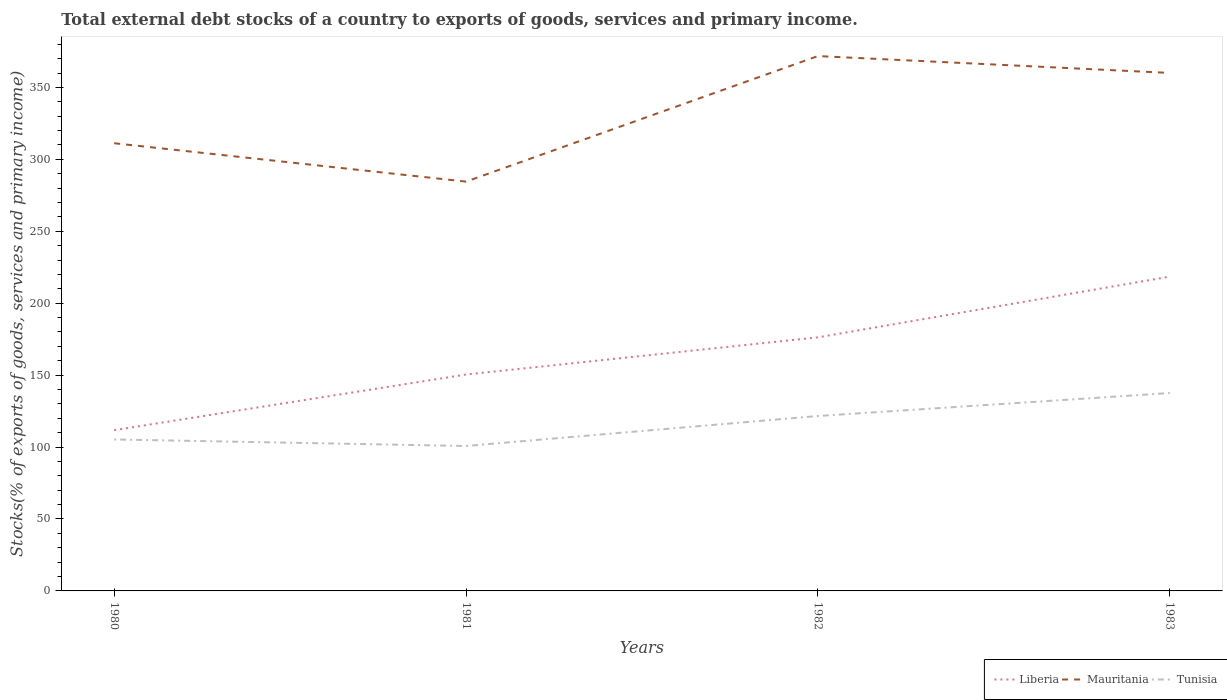Does the line corresponding to Mauritania intersect with the line corresponding to Tunisia?
Your response must be concise. No. Is the number of lines equal to the number of legend labels?
Provide a short and direct response. Yes. Across all years, what is the maximum total debt stocks in Tunisia?
Offer a terse response. 100.75. What is the total total debt stocks in Tunisia in the graph?
Offer a terse response. -16.3. What is the difference between the highest and the second highest total debt stocks in Tunisia?
Offer a very short reply. 36.81. What is the difference between the highest and the lowest total debt stocks in Mauritania?
Your answer should be very brief. 2. Is the total debt stocks in Liberia strictly greater than the total debt stocks in Mauritania over the years?
Provide a short and direct response. Yes. Are the values on the major ticks of Y-axis written in scientific E-notation?
Offer a terse response. No. Where does the legend appear in the graph?
Keep it short and to the point. Bottom right. How are the legend labels stacked?
Offer a terse response. Horizontal. What is the title of the graph?
Provide a succinct answer. Total external debt stocks of a country to exports of goods, services and primary income. Does "Virgin Islands" appear as one of the legend labels in the graph?
Offer a very short reply. No. What is the label or title of the Y-axis?
Give a very brief answer. Stocks(% of exports of goods, services and primary income). What is the Stocks(% of exports of goods, services and primary income) in Liberia in 1980?
Keep it short and to the point. 111.76. What is the Stocks(% of exports of goods, services and primary income) of Mauritania in 1980?
Make the answer very short. 311.19. What is the Stocks(% of exports of goods, services and primary income) of Tunisia in 1980?
Your response must be concise. 105.29. What is the Stocks(% of exports of goods, services and primary income) of Liberia in 1981?
Ensure brevity in your answer.  150.43. What is the Stocks(% of exports of goods, services and primary income) of Mauritania in 1981?
Keep it short and to the point. 284.52. What is the Stocks(% of exports of goods, services and primary income) in Tunisia in 1981?
Your answer should be very brief. 100.75. What is the Stocks(% of exports of goods, services and primary income) of Liberia in 1982?
Your response must be concise. 176.26. What is the Stocks(% of exports of goods, services and primary income) in Mauritania in 1982?
Make the answer very short. 371.77. What is the Stocks(% of exports of goods, services and primary income) of Tunisia in 1982?
Make the answer very short. 121.59. What is the Stocks(% of exports of goods, services and primary income) in Liberia in 1983?
Your answer should be very brief. 218.46. What is the Stocks(% of exports of goods, services and primary income) in Mauritania in 1983?
Your answer should be very brief. 360.05. What is the Stocks(% of exports of goods, services and primary income) in Tunisia in 1983?
Make the answer very short. 137.56. Across all years, what is the maximum Stocks(% of exports of goods, services and primary income) in Liberia?
Ensure brevity in your answer.  218.46. Across all years, what is the maximum Stocks(% of exports of goods, services and primary income) in Mauritania?
Your answer should be very brief. 371.77. Across all years, what is the maximum Stocks(% of exports of goods, services and primary income) of Tunisia?
Provide a short and direct response. 137.56. Across all years, what is the minimum Stocks(% of exports of goods, services and primary income) of Liberia?
Your answer should be compact. 111.76. Across all years, what is the minimum Stocks(% of exports of goods, services and primary income) in Mauritania?
Offer a very short reply. 284.52. Across all years, what is the minimum Stocks(% of exports of goods, services and primary income) of Tunisia?
Offer a terse response. 100.75. What is the total Stocks(% of exports of goods, services and primary income) of Liberia in the graph?
Your answer should be compact. 656.91. What is the total Stocks(% of exports of goods, services and primary income) of Mauritania in the graph?
Your response must be concise. 1327.53. What is the total Stocks(% of exports of goods, services and primary income) of Tunisia in the graph?
Your answer should be very brief. 465.18. What is the difference between the Stocks(% of exports of goods, services and primary income) of Liberia in 1980 and that in 1981?
Give a very brief answer. -38.68. What is the difference between the Stocks(% of exports of goods, services and primary income) in Mauritania in 1980 and that in 1981?
Ensure brevity in your answer.  26.67. What is the difference between the Stocks(% of exports of goods, services and primary income) of Tunisia in 1980 and that in 1981?
Provide a succinct answer. 4.54. What is the difference between the Stocks(% of exports of goods, services and primary income) of Liberia in 1980 and that in 1982?
Make the answer very short. -64.5. What is the difference between the Stocks(% of exports of goods, services and primary income) of Mauritania in 1980 and that in 1982?
Provide a short and direct response. -60.58. What is the difference between the Stocks(% of exports of goods, services and primary income) of Tunisia in 1980 and that in 1982?
Your response must be concise. -16.3. What is the difference between the Stocks(% of exports of goods, services and primary income) of Liberia in 1980 and that in 1983?
Provide a short and direct response. -106.71. What is the difference between the Stocks(% of exports of goods, services and primary income) of Mauritania in 1980 and that in 1983?
Provide a succinct answer. -48.86. What is the difference between the Stocks(% of exports of goods, services and primary income) in Tunisia in 1980 and that in 1983?
Provide a succinct answer. -32.27. What is the difference between the Stocks(% of exports of goods, services and primary income) of Liberia in 1981 and that in 1982?
Keep it short and to the point. -25.83. What is the difference between the Stocks(% of exports of goods, services and primary income) in Mauritania in 1981 and that in 1982?
Provide a short and direct response. -87.26. What is the difference between the Stocks(% of exports of goods, services and primary income) of Tunisia in 1981 and that in 1982?
Offer a very short reply. -20.85. What is the difference between the Stocks(% of exports of goods, services and primary income) in Liberia in 1981 and that in 1983?
Provide a short and direct response. -68.03. What is the difference between the Stocks(% of exports of goods, services and primary income) of Mauritania in 1981 and that in 1983?
Your response must be concise. -75.53. What is the difference between the Stocks(% of exports of goods, services and primary income) in Tunisia in 1981 and that in 1983?
Offer a terse response. -36.81. What is the difference between the Stocks(% of exports of goods, services and primary income) of Liberia in 1982 and that in 1983?
Keep it short and to the point. -42.2. What is the difference between the Stocks(% of exports of goods, services and primary income) in Mauritania in 1982 and that in 1983?
Provide a short and direct response. 11.72. What is the difference between the Stocks(% of exports of goods, services and primary income) of Tunisia in 1982 and that in 1983?
Give a very brief answer. -15.96. What is the difference between the Stocks(% of exports of goods, services and primary income) in Liberia in 1980 and the Stocks(% of exports of goods, services and primary income) in Mauritania in 1981?
Make the answer very short. -172.76. What is the difference between the Stocks(% of exports of goods, services and primary income) in Liberia in 1980 and the Stocks(% of exports of goods, services and primary income) in Tunisia in 1981?
Provide a succinct answer. 11.01. What is the difference between the Stocks(% of exports of goods, services and primary income) of Mauritania in 1980 and the Stocks(% of exports of goods, services and primary income) of Tunisia in 1981?
Keep it short and to the point. 210.44. What is the difference between the Stocks(% of exports of goods, services and primary income) of Liberia in 1980 and the Stocks(% of exports of goods, services and primary income) of Mauritania in 1982?
Your answer should be compact. -260.02. What is the difference between the Stocks(% of exports of goods, services and primary income) of Liberia in 1980 and the Stocks(% of exports of goods, services and primary income) of Tunisia in 1982?
Make the answer very short. -9.84. What is the difference between the Stocks(% of exports of goods, services and primary income) in Mauritania in 1980 and the Stocks(% of exports of goods, services and primary income) in Tunisia in 1982?
Keep it short and to the point. 189.6. What is the difference between the Stocks(% of exports of goods, services and primary income) of Liberia in 1980 and the Stocks(% of exports of goods, services and primary income) of Mauritania in 1983?
Offer a very short reply. -248.29. What is the difference between the Stocks(% of exports of goods, services and primary income) of Liberia in 1980 and the Stocks(% of exports of goods, services and primary income) of Tunisia in 1983?
Keep it short and to the point. -25.8. What is the difference between the Stocks(% of exports of goods, services and primary income) in Mauritania in 1980 and the Stocks(% of exports of goods, services and primary income) in Tunisia in 1983?
Keep it short and to the point. 173.63. What is the difference between the Stocks(% of exports of goods, services and primary income) in Liberia in 1981 and the Stocks(% of exports of goods, services and primary income) in Mauritania in 1982?
Your answer should be compact. -221.34. What is the difference between the Stocks(% of exports of goods, services and primary income) of Liberia in 1981 and the Stocks(% of exports of goods, services and primary income) of Tunisia in 1982?
Provide a succinct answer. 28.84. What is the difference between the Stocks(% of exports of goods, services and primary income) of Mauritania in 1981 and the Stocks(% of exports of goods, services and primary income) of Tunisia in 1982?
Your answer should be very brief. 162.93. What is the difference between the Stocks(% of exports of goods, services and primary income) of Liberia in 1981 and the Stocks(% of exports of goods, services and primary income) of Mauritania in 1983?
Your answer should be compact. -209.62. What is the difference between the Stocks(% of exports of goods, services and primary income) of Liberia in 1981 and the Stocks(% of exports of goods, services and primary income) of Tunisia in 1983?
Ensure brevity in your answer.  12.88. What is the difference between the Stocks(% of exports of goods, services and primary income) in Mauritania in 1981 and the Stocks(% of exports of goods, services and primary income) in Tunisia in 1983?
Give a very brief answer. 146.96. What is the difference between the Stocks(% of exports of goods, services and primary income) in Liberia in 1982 and the Stocks(% of exports of goods, services and primary income) in Mauritania in 1983?
Make the answer very short. -183.79. What is the difference between the Stocks(% of exports of goods, services and primary income) of Liberia in 1982 and the Stocks(% of exports of goods, services and primary income) of Tunisia in 1983?
Give a very brief answer. 38.71. What is the difference between the Stocks(% of exports of goods, services and primary income) of Mauritania in 1982 and the Stocks(% of exports of goods, services and primary income) of Tunisia in 1983?
Your answer should be compact. 234.22. What is the average Stocks(% of exports of goods, services and primary income) in Liberia per year?
Offer a very short reply. 164.23. What is the average Stocks(% of exports of goods, services and primary income) in Mauritania per year?
Your response must be concise. 331.88. What is the average Stocks(% of exports of goods, services and primary income) in Tunisia per year?
Give a very brief answer. 116.3. In the year 1980, what is the difference between the Stocks(% of exports of goods, services and primary income) in Liberia and Stocks(% of exports of goods, services and primary income) in Mauritania?
Give a very brief answer. -199.43. In the year 1980, what is the difference between the Stocks(% of exports of goods, services and primary income) of Liberia and Stocks(% of exports of goods, services and primary income) of Tunisia?
Your response must be concise. 6.47. In the year 1980, what is the difference between the Stocks(% of exports of goods, services and primary income) of Mauritania and Stocks(% of exports of goods, services and primary income) of Tunisia?
Make the answer very short. 205.9. In the year 1981, what is the difference between the Stocks(% of exports of goods, services and primary income) of Liberia and Stocks(% of exports of goods, services and primary income) of Mauritania?
Keep it short and to the point. -134.08. In the year 1981, what is the difference between the Stocks(% of exports of goods, services and primary income) in Liberia and Stocks(% of exports of goods, services and primary income) in Tunisia?
Your answer should be compact. 49.69. In the year 1981, what is the difference between the Stocks(% of exports of goods, services and primary income) in Mauritania and Stocks(% of exports of goods, services and primary income) in Tunisia?
Your answer should be compact. 183.77. In the year 1982, what is the difference between the Stocks(% of exports of goods, services and primary income) in Liberia and Stocks(% of exports of goods, services and primary income) in Mauritania?
Your response must be concise. -195.51. In the year 1982, what is the difference between the Stocks(% of exports of goods, services and primary income) of Liberia and Stocks(% of exports of goods, services and primary income) of Tunisia?
Your answer should be very brief. 54.67. In the year 1982, what is the difference between the Stocks(% of exports of goods, services and primary income) in Mauritania and Stocks(% of exports of goods, services and primary income) in Tunisia?
Offer a very short reply. 250.18. In the year 1983, what is the difference between the Stocks(% of exports of goods, services and primary income) in Liberia and Stocks(% of exports of goods, services and primary income) in Mauritania?
Your response must be concise. -141.59. In the year 1983, what is the difference between the Stocks(% of exports of goods, services and primary income) in Liberia and Stocks(% of exports of goods, services and primary income) in Tunisia?
Ensure brevity in your answer.  80.91. In the year 1983, what is the difference between the Stocks(% of exports of goods, services and primary income) of Mauritania and Stocks(% of exports of goods, services and primary income) of Tunisia?
Provide a short and direct response. 222.49. What is the ratio of the Stocks(% of exports of goods, services and primary income) of Liberia in 1980 to that in 1981?
Ensure brevity in your answer.  0.74. What is the ratio of the Stocks(% of exports of goods, services and primary income) in Mauritania in 1980 to that in 1981?
Your answer should be very brief. 1.09. What is the ratio of the Stocks(% of exports of goods, services and primary income) of Tunisia in 1980 to that in 1981?
Your answer should be very brief. 1.05. What is the ratio of the Stocks(% of exports of goods, services and primary income) in Liberia in 1980 to that in 1982?
Offer a very short reply. 0.63. What is the ratio of the Stocks(% of exports of goods, services and primary income) of Mauritania in 1980 to that in 1982?
Provide a succinct answer. 0.84. What is the ratio of the Stocks(% of exports of goods, services and primary income) in Tunisia in 1980 to that in 1982?
Your answer should be compact. 0.87. What is the ratio of the Stocks(% of exports of goods, services and primary income) in Liberia in 1980 to that in 1983?
Offer a very short reply. 0.51. What is the ratio of the Stocks(% of exports of goods, services and primary income) in Mauritania in 1980 to that in 1983?
Offer a very short reply. 0.86. What is the ratio of the Stocks(% of exports of goods, services and primary income) of Tunisia in 1980 to that in 1983?
Your answer should be very brief. 0.77. What is the ratio of the Stocks(% of exports of goods, services and primary income) in Liberia in 1981 to that in 1982?
Make the answer very short. 0.85. What is the ratio of the Stocks(% of exports of goods, services and primary income) of Mauritania in 1981 to that in 1982?
Provide a short and direct response. 0.77. What is the ratio of the Stocks(% of exports of goods, services and primary income) in Tunisia in 1981 to that in 1982?
Provide a short and direct response. 0.83. What is the ratio of the Stocks(% of exports of goods, services and primary income) of Liberia in 1981 to that in 1983?
Provide a short and direct response. 0.69. What is the ratio of the Stocks(% of exports of goods, services and primary income) of Mauritania in 1981 to that in 1983?
Your response must be concise. 0.79. What is the ratio of the Stocks(% of exports of goods, services and primary income) of Tunisia in 1981 to that in 1983?
Provide a short and direct response. 0.73. What is the ratio of the Stocks(% of exports of goods, services and primary income) of Liberia in 1982 to that in 1983?
Ensure brevity in your answer.  0.81. What is the ratio of the Stocks(% of exports of goods, services and primary income) of Mauritania in 1982 to that in 1983?
Ensure brevity in your answer.  1.03. What is the ratio of the Stocks(% of exports of goods, services and primary income) of Tunisia in 1982 to that in 1983?
Your answer should be compact. 0.88. What is the difference between the highest and the second highest Stocks(% of exports of goods, services and primary income) of Liberia?
Keep it short and to the point. 42.2. What is the difference between the highest and the second highest Stocks(% of exports of goods, services and primary income) of Mauritania?
Ensure brevity in your answer.  11.72. What is the difference between the highest and the second highest Stocks(% of exports of goods, services and primary income) of Tunisia?
Give a very brief answer. 15.96. What is the difference between the highest and the lowest Stocks(% of exports of goods, services and primary income) of Liberia?
Make the answer very short. 106.71. What is the difference between the highest and the lowest Stocks(% of exports of goods, services and primary income) in Mauritania?
Your answer should be very brief. 87.26. What is the difference between the highest and the lowest Stocks(% of exports of goods, services and primary income) in Tunisia?
Your answer should be very brief. 36.81. 